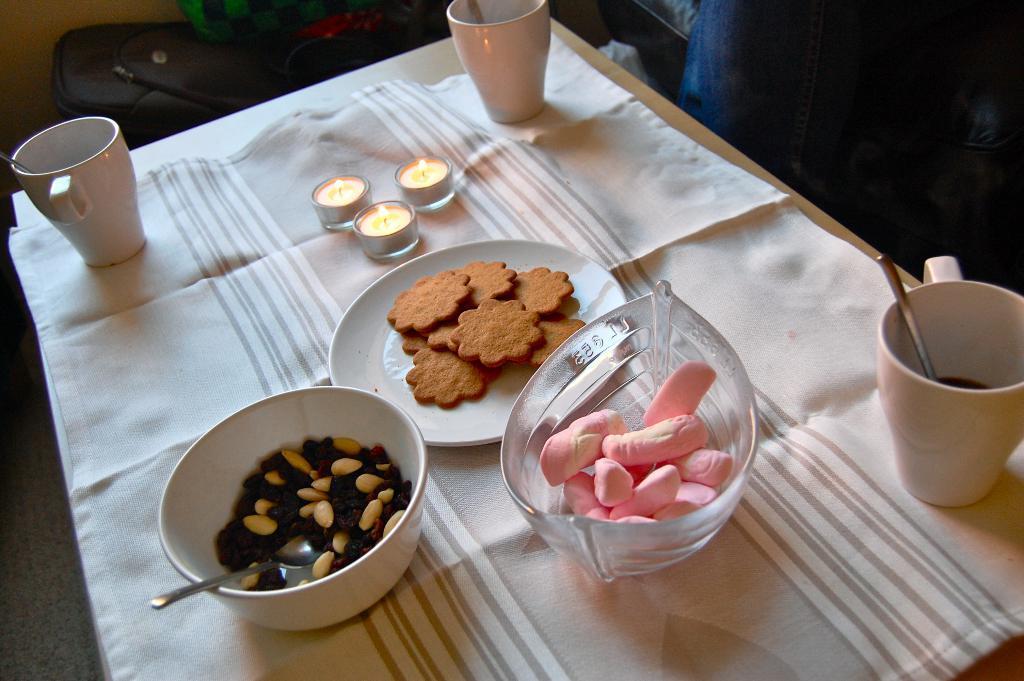Can you describe this image briefly? This image consists of a table covered with a white cloth on which there are cookies along with nut in a bowl. And there are three candles kept on the cloth. 